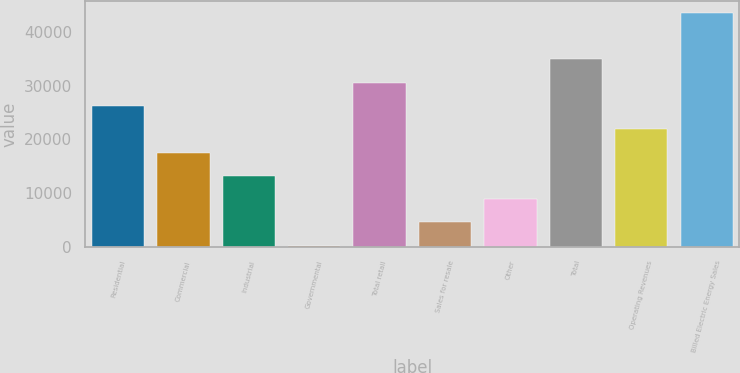Convert chart to OTSL. <chart><loc_0><loc_0><loc_500><loc_500><bar_chart><fcel>Residential<fcel>Commercial<fcel>Industrial<fcel>Governmental<fcel>Total retail<fcel>Sales for resale<fcel>Other<fcel>Total<fcel>Operating Revenues<fcel>Billed Electric Energy Sales<nl><fcel>26194<fcel>17531<fcel>13199.5<fcel>205<fcel>30525.5<fcel>4536.5<fcel>8868<fcel>34857<fcel>21862.5<fcel>43520<nl></chart> 